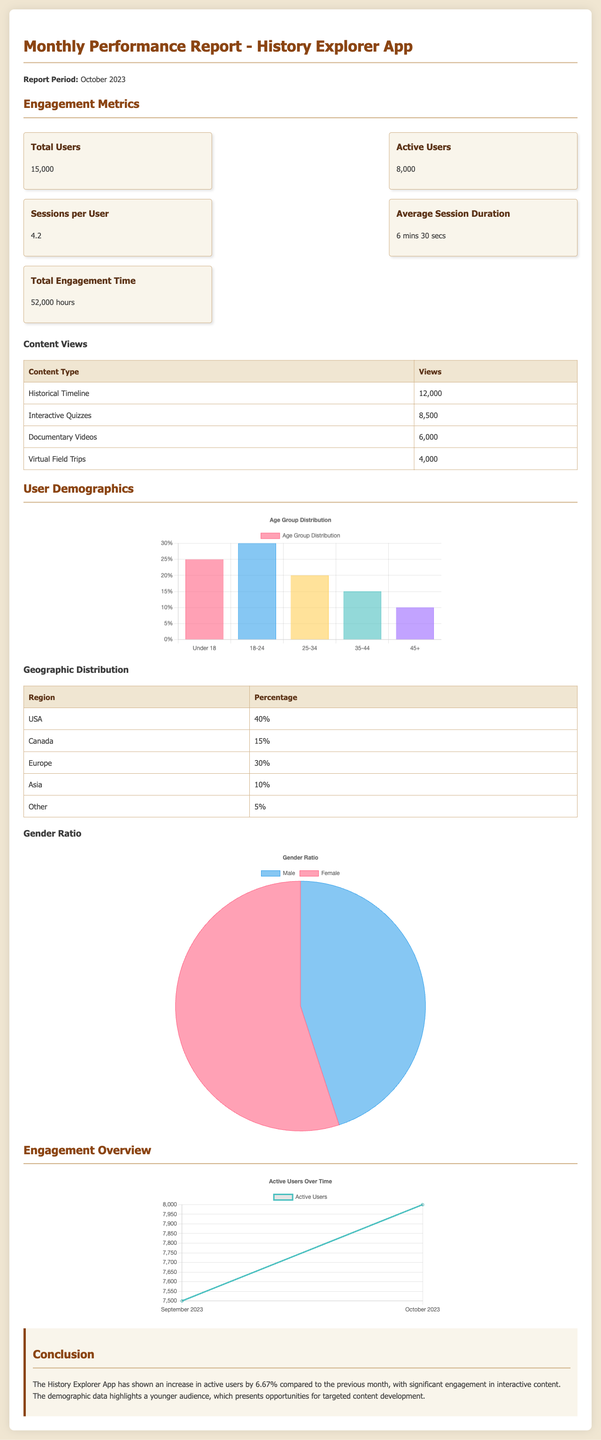What was the total number of users in October 2023? The total number of users is listed in the engagement metrics section as 15,000.
Answer: 15,000 What is the percentage of active users? Active users are provided in the metrics section, showing 8,000 out of 15,000 total users, which translates to 53.33%.
Answer: 53.33% How long is the average session duration? The document states that the average session duration is 6 minutes and 30 seconds.
Answer: 6 mins 30 secs Which content type had the highest views? In the content views table, the Historical Timeline has the highest number of views listed at 12,000.
Answer: Historical Timeline What percentage of users are from the USA? The geographic distribution table indicates that 40% of users are from the USA.
Answer: 40% What is the gender ratio of the users? The gender chart shows the distribution as 45% male and 55% female.
Answer: 45% male, 55% female How many total hours were engaged by users? The total engagement time is stated as 52,000 hours in the metrics section.
Answer: 52,000 hours What is the increase in active users compared to the previous month? The conclusion mentions a 6.67% increase in active users from the previous month.
Answer: 6.67% What is the total number of views for Interactive Quizzes? The content views table lists the views for Interactive Quizzes as 8,500.
Answer: 8,500 